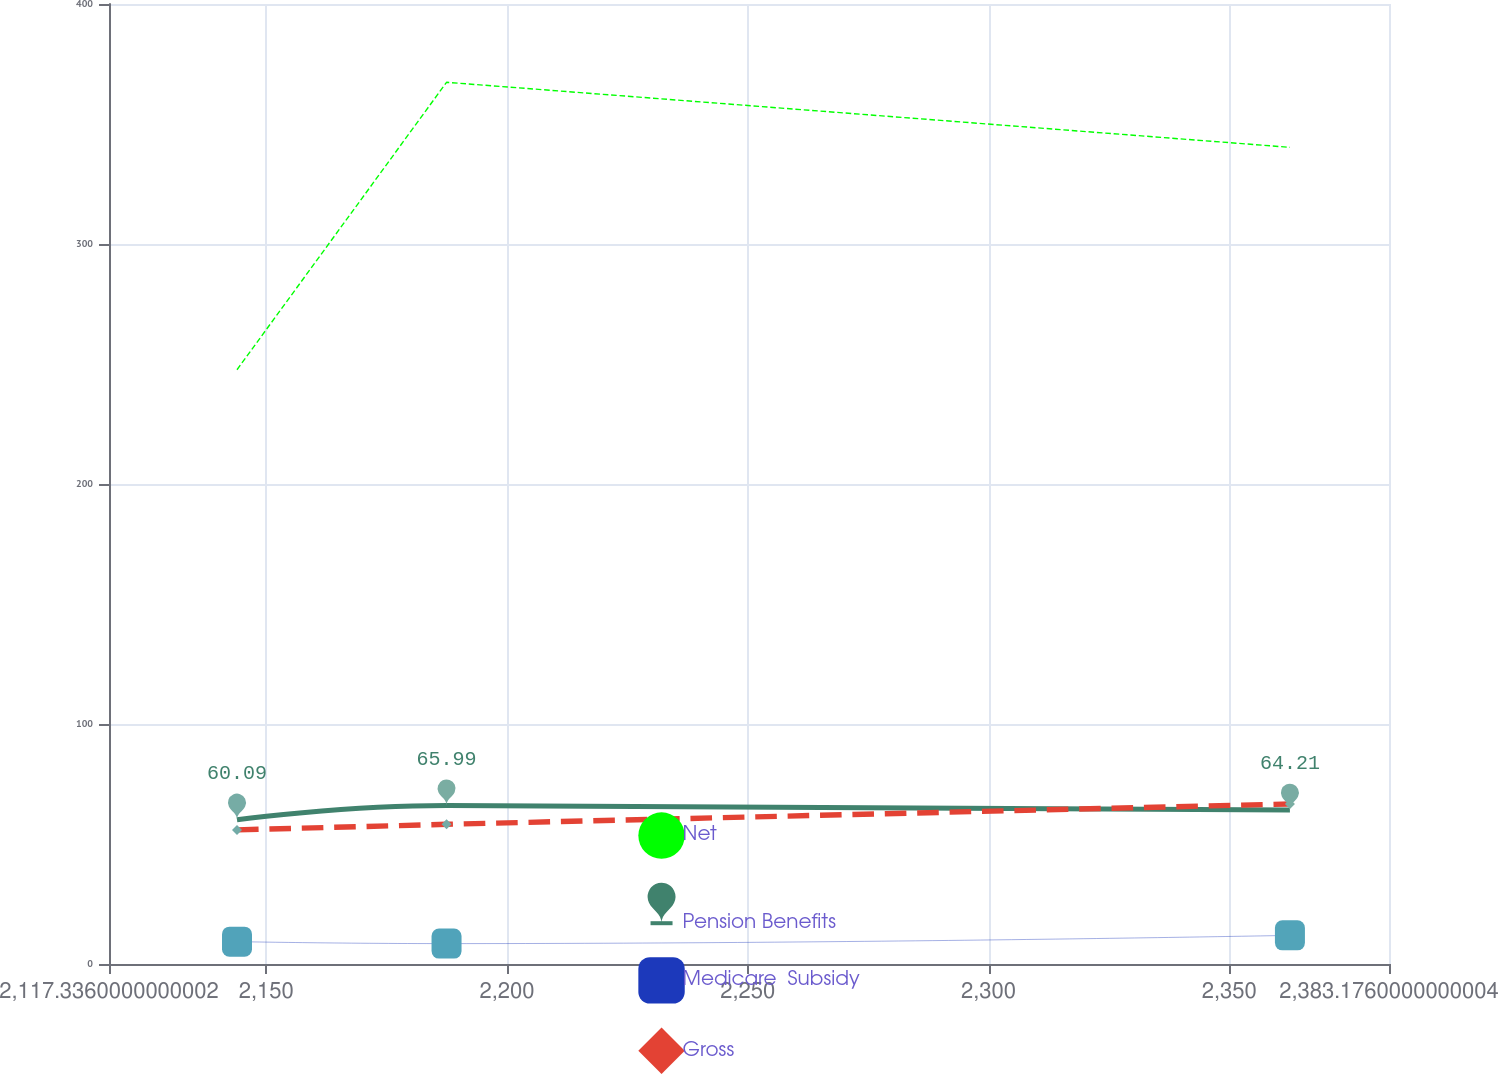Convert chart. <chart><loc_0><loc_0><loc_500><loc_500><line_chart><ecel><fcel>Net<fcel>Pension Benefits<fcel>Medicare  Subsidy<fcel>Gross<nl><fcel>2143.92<fcel>247.61<fcel>60.09<fcel>9.32<fcel>55.88<nl><fcel>2187.44<fcel>367.38<fcel>65.99<fcel>8.5<fcel>58.2<nl><fcel>2362.6<fcel>340.28<fcel>64.21<fcel>11.93<fcel>66.69<nl><fcel>2386.18<fcel>321.63<fcel>67.77<fcel>11.61<fcel>51.9<nl><fcel>2409.76<fcel>432.05<fcel>77.88<fcel>9.88<fcel>62.02<nl></chart> 